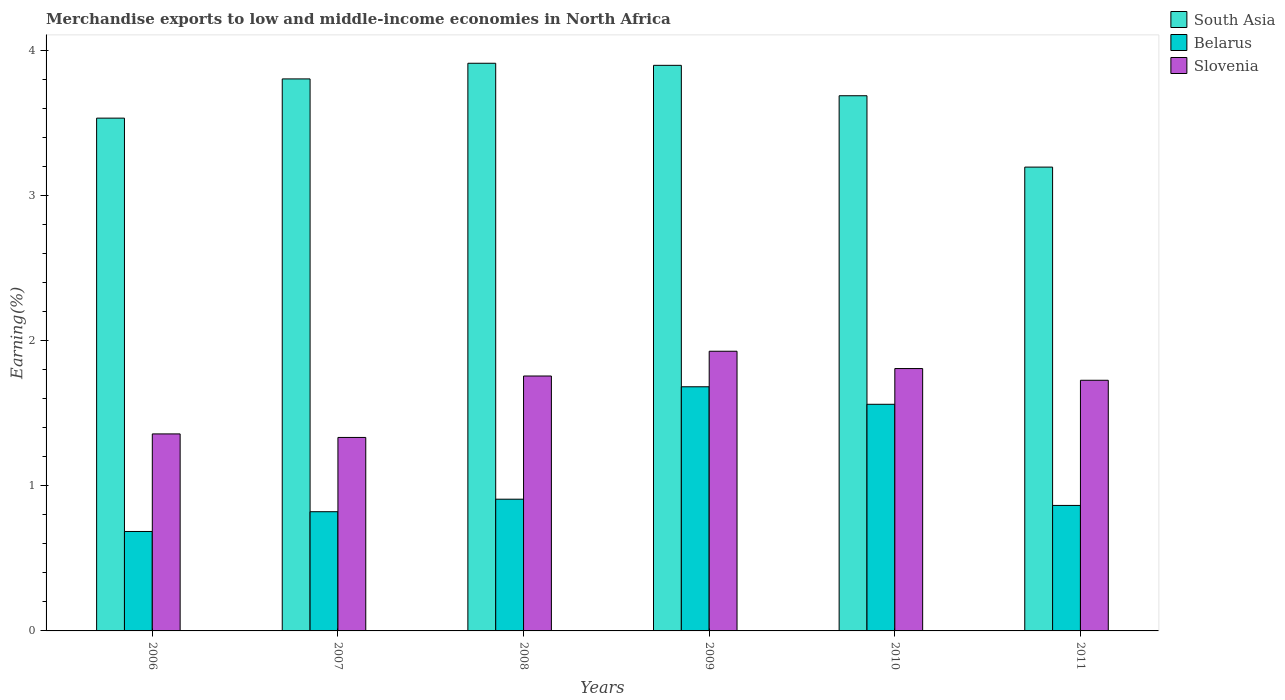How many different coloured bars are there?
Keep it short and to the point. 3. How many groups of bars are there?
Your response must be concise. 6. Are the number of bars on each tick of the X-axis equal?
Offer a terse response. Yes. How many bars are there on the 4th tick from the left?
Ensure brevity in your answer.  3. How many bars are there on the 1st tick from the right?
Offer a very short reply. 3. What is the percentage of amount earned from merchandise exports in South Asia in 2011?
Provide a short and direct response. 3.2. Across all years, what is the maximum percentage of amount earned from merchandise exports in Belarus?
Offer a very short reply. 1.68. Across all years, what is the minimum percentage of amount earned from merchandise exports in Slovenia?
Your answer should be compact. 1.33. What is the total percentage of amount earned from merchandise exports in South Asia in the graph?
Keep it short and to the point. 22.03. What is the difference between the percentage of amount earned from merchandise exports in Belarus in 2007 and that in 2011?
Keep it short and to the point. -0.04. What is the difference between the percentage of amount earned from merchandise exports in Belarus in 2009 and the percentage of amount earned from merchandise exports in Slovenia in 2006?
Keep it short and to the point. 0.32. What is the average percentage of amount earned from merchandise exports in Belarus per year?
Your answer should be very brief. 1.09. In the year 2007, what is the difference between the percentage of amount earned from merchandise exports in Belarus and percentage of amount earned from merchandise exports in South Asia?
Offer a very short reply. -2.98. In how many years, is the percentage of amount earned from merchandise exports in Belarus greater than 0.8 %?
Offer a terse response. 5. What is the ratio of the percentage of amount earned from merchandise exports in Belarus in 2007 to that in 2009?
Your answer should be compact. 0.49. What is the difference between the highest and the second highest percentage of amount earned from merchandise exports in Belarus?
Provide a short and direct response. 0.12. What is the difference between the highest and the lowest percentage of amount earned from merchandise exports in Belarus?
Offer a terse response. 1. Is the sum of the percentage of amount earned from merchandise exports in Slovenia in 2008 and 2010 greater than the maximum percentage of amount earned from merchandise exports in Belarus across all years?
Ensure brevity in your answer.  Yes. What does the 2nd bar from the left in 2008 represents?
Keep it short and to the point. Belarus. What does the 2nd bar from the right in 2010 represents?
Provide a short and direct response. Belarus. Is it the case that in every year, the sum of the percentage of amount earned from merchandise exports in Belarus and percentage of amount earned from merchandise exports in Slovenia is greater than the percentage of amount earned from merchandise exports in South Asia?
Provide a short and direct response. No. What is the difference between two consecutive major ticks on the Y-axis?
Your response must be concise. 1. Are the values on the major ticks of Y-axis written in scientific E-notation?
Offer a terse response. No. Does the graph contain grids?
Ensure brevity in your answer.  No. How many legend labels are there?
Your answer should be very brief. 3. How are the legend labels stacked?
Provide a short and direct response. Vertical. What is the title of the graph?
Provide a succinct answer. Merchandise exports to low and middle-income economies in North Africa. Does "Channel Islands" appear as one of the legend labels in the graph?
Your response must be concise. No. What is the label or title of the Y-axis?
Provide a succinct answer. Earning(%). What is the Earning(%) in South Asia in 2006?
Offer a very short reply. 3.53. What is the Earning(%) in Belarus in 2006?
Keep it short and to the point. 0.69. What is the Earning(%) of Slovenia in 2006?
Your answer should be very brief. 1.36. What is the Earning(%) in South Asia in 2007?
Your response must be concise. 3.8. What is the Earning(%) of Belarus in 2007?
Your answer should be very brief. 0.82. What is the Earning(%) of Slovenia in 2007?
Your answer should be compact. 1.33. What is the Earning(%) in South Asia in 2008?
Your answer should be compact. 3.91. What is the Earning(%) of Belarus in 2008?
Your response must be concise. 0.91. What is the Earning(%) in Slovenia in 2008?
Keep it short and to the point. 1.76. What is the Earning(%) of South Asia in 2009?
Offer a very short reply. 3.9. What is the Earning(%) in Belarus in 2009?
Your response must be concise. 1.68. What is the Earning(%) in Slovenia in 2009?
Provide a succinct answer. 1.93. What is the Earning(%) in South Asia in 2010?
Provide a short and direct response. 3.69. What is the Earning(%) of Belarus in 2010?
Your answer should be compact. 1.56. What is the Earning(%) of Slovenia in 2010?
Offer a terse response. 1.81. What is the Earning(%) of South Asia in 2011?
Offer a very short reply. 3.2. What is the Earning(%) of Belarus in 2011?
Your answer should be compact. 0.86. What is the Earning(%) in Slovenia in 2011?
Make the answer very short. 1.73. Across all years, what is the maximum Earning(%) in South Asia?
Keep it short and to the point. 3.91. Across all years, what is the maximum Earning(%) in Belarus?
Provide a short and direct response. 1.68. Across all years, what is the maximum Earning(%) of Slovenia?
Offer a very short reply. 1.93. Across all years, what is the minimum Earning(%) in South Asia?
Give a very brief answer. 3.2. Across all years, what is the minimum Earning(%) in Belarus?
Provide a short and direct response. 0.69. Across all years, what is the minimum Earning(%) in Slovenia?
Keep it short and to the point. 1.33. What is the total Earning(%) in South Asia in the graph?
Keep it short and to the point. 22.03. What is the total Earning(%) of Belarus in the graph?
Keep it short and to the point. 6.52. What is the total Earning(%) of Slovenia in the graph?
Give a very brief answer. 9.91. What is the difference between the Earning(%) in South Asia in 2006 and that in 2007?
Offer a terse response. -0.27. What is the difference between the Earning(%) of Belarus in 2006 and that in 2007?
Give a very brief answer. -0.14. What is the difference between the Earning(%) of Slovenia in 2006 and that in 2007?
Make the answer very short. 0.02. What is the difference between the Earning(%) in South Asia in 2006 and that in 2008?
Provide a short and direct response. -0.38. What is the difference between the Earning(%) of Belarus in 2006 and that in 2008?
Your answer should be very brief. -0.22. What is the difference between the Earning(%) in Slovenia in 2006 and that in 2008?
Ensure brevity in your answer.  -0.4. What is the difference between the Earning(%) in South Asia in 2006 and that in 2009?
Offer a very short reply. -0.36. What is the difference between the Earning(%) in Belarus in 2006 and that in 2009?
Provide a short and direct response. -1. What is the difference between the Earning(%) in Slovenia in 2006 and that in 2009?
Provide a succinct answer. -0.57. What is the difference between the Earning(%) in South Asia in 2006 and that in 2010?
Keep it short and to the point. -0.15. What is the difference between the Earning(%) of Belarus in 2006 and that in 2010?
Provide a succinct answer. -0.88. What is the difference between the Earning(%) of Slovenia in 2006 and that in 2010?
Provide a succinct answer. -0.45. What is the difference between the Earning(%) in South Asia in 2006 and that in 2011?
Your response must be concise. 0.34. What is the difference between the Earning(%) of Belarus in 2006 and that in 2011?
Your response must be concise. -0.18. What is the difference between the Earning(%) in Slovenia in 2006 and that in 2011?
Make the answer very short. -0.37. What is the difference between the Earning(%) of South Asia in 2007 and that in 2008?
Provide a succinct answer. -0.11. What is the difference between the Earning(%) in Belarus in 2007 and that in 2008?
Offer a terse response. -0.09. What is the difference between the Earning(%) of Slovenia in 2007 and that in 2008?
Offer a terse response. -0.42. What is the difference between the Earning(%) of South Asia in 2007 and that in 2009?
Offer a very short reply. -0.09. What is the difference between the Earning(%) of Belarus in 2007 and that in 2009?
Your response must be concise. -0.86. What is the difference between the Earning(%) of Slovenia in 2007 and that in 2009?
Your response must be concise. -0.59. What is the difference between the Earning(%) of South Asia in 2007 and that in 2010?
Ensure brevity in your answer.  0.12. What is the difference between the Earning(%) of Belarus in 2007 and that in 2010?
Provide a short and direct response. -0.74. What is the difference between the Earning(%) in Slovenia in 2007 and that in 2010?
Provide a succinct answer. -0.47. What is the difference between the Earning(%) of South Asia in 2007 and that in 2011?
Your answer should be very brief. 0.61. What is the difference between the Earning(%) in Belarus in 2007 and that in 2011?
Offer a very short reply. -0.04. What is the difference between the Earning(%) of Slovenia in 2007 and that in 2011?
Keep it short and to the point. -0.39. What is the difference between the Earning(%) in South Asia in 2008 and that in 2009?
Your answer should be compact. 0.01. What is the difference between the Earning(%) of Belarus in 2008 and that in 2009?
Provide a short and direct response. -0.77. What is the difference between the Earning(%) in Slovenia in 2008 and that in 2009?
Give a very brief answer. -0.17. What is the difference between the Earning(%) in South Asia in 2008 and that in 2010?
Offer a very short reply. 0.22. What is the difference between the Earning(%) in Belarus in 2008 and that in 2010?
Keep it short and to the point. -0.65. What is the difference between the Earning(%) of Slovenia in 2008 and that in 2010?
Provide a short and direct response. -0.05. What is the difference between the Earning(%) in South Asia in 2008 and that in 2011?
Your answer should be very brief. 0.72. What is the difference between the Earning(%) of Belarus in 2008 and that in 2011?
Your answer should be compact. 0.04. What is the difference between the Earning(%) in Slovenia in 2008 and that in 2011?
Keep it short and to the point. 0.03. What is the difference between the Earning(%) in South Asia in 2009 and that in 2010?
Offer a terse response. 0.21. What is the difference between the Earning(%) in Belarus in 2009 and that in 2010?
Your answer should be very brief. 0.12. What is the difference between the Earning(%) of Slovenia in 2009 and that in 2010?
Your response must be concise. 0.12. What is the difference between the Earning(%) in South Asia in 2009 and that in 2011?
Your answer should be compact. 0.7. What is the difference between the Earning(%) in Belarus in 2009 and that in 2011?
Keep it short and to the point. 0.82. What is the difference between the Earning(%) in Slovenia in 2009 and that in 2011?
Make the answer very short. 0.2. What is the difference between the Earning(%) in South Asia in 2010 and that in 2011?
Offer a terse response. 0.49. What is the difference between the Earning(%) in Belarus in 2010 and that in 2011?
Your answer should be compact. 0.7. What is the difference between the Earning(%) in Slovenia in 2010 and that in 2011?
Offer a terse response. 0.08. What is the difference between the Earning(%) in South Asia in 2006 and the Earning(%) in Belarus in 2007?
Offer a terse response. 2.71. What is the difference between the Earning(%) in South Asia in 2006 and the Earning(%) in Slovenia in 2007?
Offer a terse response. 2.2. What is the difference between the Earning(%) in Belarus in 2006 and the Earning(%) in Slovenia in 2007?
Your answer should be very brief. -0.65. What is the difference between the Earning(%) in South Asia in 2006 and the Earning(%) in Belarus in 2008?
Offer a terse response. 2.63. What is the difference between the Earning(%) of South Asia in 2006 and the Earning(%) of Slovenia in 2008?
Ensure brevity in your answer.  1.78. What is the difference between the Earning(%) of Belarus in 2006 and the Earning(%) of Slovenia in 2008?
Provide a short and direct response. -1.07. What is the difference between the Earning(%) in South Asia in 2006 and the Earning(%) in Belarus in 2009?
Your answer should be compact. 1.85. What is the difference between the Earning(%) in South Asia in 2006 and the Earning(%) in Slovenia in 2009?
Provide a short and direct response. 1.61. What is the difference between the Earning(%) of Belarus in 2006 and the Earning(%) of Slovenia in 2009?
Give a very brief answer. -1.24. What is the difference between the Earning(%) in South Asia in 2006 and the Earning(%) in Belarus in 2010?
Give a very brief answer. 1.97. What is the difference between the Earning(%) of South Asia in 2006 and the Earning(%) of Slovenia in 2010?
Your answer should be very brief. 1.73. What is the difference between the Earning(%) of Belarus in 2006 and the Earning(%) of Slovenia in 2010?
Give a very brief answer. -1.12. What is the difference between the Earning(%) of South Asia in 2006 and the Earning(%) of Belarus in 2011?
Your response must be concise. 2.67. What is the difference between the Earning(%) in South Asia in 2006 and the Earning(%) in Slovenia in 2011?
Give a very brief answer. 1.81. What is the difference between the Earning(%) in Belarus in 2006 and the Earning(%) in Slovenia in 2011?
Give a very brief answer. -1.04. What is the difference between the Earning(%) in South Asia in 2007 and the Earning(%) in Belarus in 2008?
Your response must be concise. 2.9. What is the difference between the Earning(%) of South Asia in 2007 and the Earning(%) of Slovenia in 2008?
Your response must be concise. 2.05. What is the difference between the Earning(%) of Belarus in 2007 and the Earning(%) of Slovenia in 2008?
Provide a short and direct response. -0.94. What is the difference between the Earning(%) of South Asia in 2007 and the Earning(%) of Belarus in 2009?
Provide a short and direct response. 2.12. What is the difference between the Earning(%) in South Asia in 2007 and the Earning(%) in Slovenia in 2009?
Your response must be concise. 1.88. What is the difference between the Earning(%) in Belarus in 2007 and the Earning(%) in Slovenia in 2009?
Provide a short and direct response. -1.11. What is the difference between the Earning(%) in South Asia in 2007 and the Earning(%) in Belarus in 2010?
Provide a succinct answer. 2.24. What is the difference between the Earning(%) of South Asia in 2007 and the Earning(%) of Slovenia in 2010?
Provide a short and direct response. 2. What is the difference between the Earning(%) of Belarus in 2007 and the Earning(%) of Slovenia in 2010?
Offer a terse response. -0.99. What is the difference between the Earning(%) in South Asia in 2007 and the Earning(%) in Belarus in 2011?
Provide a short and direct response. 2.94. What is the difference between the Earning(%) in South Asia in 2007 and the Earning(%) in Slovenia in 2011?
Your response must be concise. 2.08. What is the difference between the Earning(%) of Belarus in 2007 and the Earning(%) of Slovenia in 2011?
Your answer should be compact. -0.91. What is the difference between the Earning(%) in South Asia in 2008 and the Earning(%) in Belarus in 2009?
Keep it short and to the point. 2.23. What is the difference between the Earning(%) in South Asia in 2008 and the Earning(%) in Slovenia in 2009?
Your answer should be compact. 1.98. What is the difference between the Earning(%) in Belarus in 2008 and the Earning(%) in Slovenia in 2009?
Give a very brief answer. -1.02. What is the difference between the Earning(%) in South Asia in 2008 and the Earning(%) in Belarus in 2010?
Your response must be concise. 2.35. What is the difference between the Earning(%) of South Asia in 2008 and the Earning(%) of Slovenia in 2010?
Your answer should be compact. 2.1. What is the difference between the Earning(%) in Belarus in 2008 and the Earning(%) in Slovenia in 2010?
Provide a succinct answer. -0.9. What is the difference between the Earning(%) of South Asia in 2008 and the Earning(%) of Belarus in 2011?
Provide a short and direct response. 3.05. What is the difference between the Earning(%) of South Asia in 2008 and the Earning(%) of Slovenia in 2011?
Ensure brevity in your answer.  2.18. What is the difference between the Earning(%) in Belarus in 2008 and the Earning(%) in Slovenia in 2011?
Provide a succinct answer. -0.82. What is the difference between the Earning(%) of South Asia in 2009 and the Earning(%) of Belarus in 2010?
Provide a succinct answer. 2.34. What is the difference between the Earning(%) of South Asia in 2009 and the Earning(%) of Slovenia in 2010?
Offer a very short reply. 2.09. What is the difference between the Earning(%) of Belarus in 2009 and the Earning(%) of Slovenia in 2010?
Give a very brief answer. -0.13. What is the difference between the Earning(%) in South Asia in 2009 and the Earning(%) in Belarus in 2011?
Ensure brevity in your answer.  3.03. What is the difference between the Earning(%) of South Asia in 2009 and the Earning(%) of Slovenia in 2011?
Provide a short and direct response. 2.17. What is the difference between the Earning(%) of Belarus in 2009 and the Earning(%) of Slovenia in 2011?
Your response must be concise. -0.04. What is the difference between the Earning(%) in South Asia in 2010 and the Earning(%) in Belarus in 2011?
Provide a succinct answer. 2.82. What is the difference between the Earning(%) of South Asia in 2010 and the Earning(%) of Slovenia in 2011?
Provide a short and direct response. 1.96. What is the difference between the Earning(%) in Belarus in 2010 and the Earning(%) in Slovenia in 2011?
Provide a short and direct response. -0.17. What is the average Earning(%) of South Asia per year?
Make the answer very short. 3.67. What is the average Earning(%) in Belarus per year?
Your response must be concise. 1.09. What is the average Earning(%) in Slovenia per year?
Provide a succinct answer. 1.65. In the year 2006, what is the difference between the Earning(%) of South Asia and Earning(%) of Belarus?
Keep it short and to the point. 2.85. In the year 2006, what is the difference between the Earning(%) of South Asia and Earning(%) of Slovenia?
Your answer should be compact. 2.18. In the year 2006, what is the difference between the Earning(%) of Belarus and Earning(%) of Slovenia?
Make the answer very short. -0.67. In the year 2007, what is the difference between the Earning(%) of South Asia and Earning(%) of Belarus?
Provide a succinct answer. 2.98. In the year 2007, what is the difference between the Earning(%) in South Asia and Earning(%) in Slovenia?
Offer a terse response. 2.47. In the year 2007, what is the difference between the Earning(%) in Belarus and Earning(%) in Slovenia?
Your response must be concise. -0.51. In the year 2008, what is the difference between the Earning(%) in South Asia and Earning(%) in Belarus?
Provide a succinct answer. 3. In the year 2008, what is the difference between the Earning(%) of South Asia and Earning(%) of Slovenia?
Make the answer very short. 2.16. In the year 2008, what is the difference between the Earning(%) of Belarus and Earning(%) of Slovenia?
Ensure brevity in your answer.  -0.85. In the year 2009, what is the difference between the Earning(%) in South Asia and Earning(%) in Belarus?
Give a very brief answer. 2.21. In the year 2009, what is the difference between the Earning(%) of South Asia and Earning(%) of Slovenia?
Your response must be concise. 1.97. In the year 2009, what is the difference between the Earning(%) of Belarus and Earning(%) of Slovenia?
Ensure brevity in your answer.  -0.24. In the year 2010, what is the difference between the Earning(%) of South Asia and Earning(%) of Belarus?
Offer a very short reply. 2.13. In the year 2010, what is the difference between the Earning(%) of South Asia and Earning(%) of Slovenia?
Provide a succinct answer. 1.88. In the year 2010, what is the difference between the Earning(%) of Belarus and Earning(%) of Slovenia?
Give a very brief answer. -0.25. In the year 2011, what is the difference between the Earning(%) of South Asia and Earning(%) of Belarus?
Provide a short and direct response. 2.33. In the year 2011, what is the difference between the Earning(%) in South Asia and Earning(%) in Slovenia?
Offer a very short reply. 1.47. In the year 2011, what is the difference between the Earning(%) of Belarus and Earning(%) of Slovenia?
Your answer should be compact. -0.86. What is the ratio of the Earning(%) of South Asia in 2006 to that in 2007?
Offer a very short reply. 0.93. What is the ratio of the Earning(%) in Belarus in 2006 to that in 2007?
Your answer should be compact. 0.83. What is the ratio of the Earning(%) in Slovenia in 2006 to that in 2007?
Provide a succinct answer. 1.02. What is the ratio of the Earning(%) in South Asia in 2006 to that in 2008?
Provide a short and direct response. 0.9. What is the ratio of the Earning(%) in Belarus in 2006 to that in 2008?
Provide a succinct answer. 0.75. What is the ratio of the Earning(%) of Slovenia in 2006 to that in 2008?
Your response must be concise. 0.77. What is the ratio of the Earning(%) in South Asia in 2006 to that in 2009?
Your response must be concise. 0.91. What is the ratio of the Earning(%) in Belarus in 2006 to that in 2009?
Provide a short and direct response. 0.41. What is the ratio of the Earning(%) in Slovenia in 2006 to that in 2009?
Provide a succinct answer. 0.7. What is the ratio of the Earning(%) in South Asia in 2006 to that in 2010?
Give a very brief answer. 0.96. What is the ratio of the Earning(%) in Belarus in 2006 to that in 2010?
Provide a short and direct response. 0.44. What is the ratio of the Earning(%) in Slovenia in 2006 to that in 2010?
Ensure brevity in your answer.  0.75. What is the ratio of the Earning(%) of South Asia in 2006 to that in 2011?
Your answer should be compact. 1.11. What is the ratio of the Earning(%) of Belarus in 2006 to that in 2011?
Make the answer very short. 0.79. What is the ratio of the Earning(%) in Slovenia in 2006 to that in 2011?
Keep it short and to the point. 0.79. What is the ratio of the Earning(%) in South Asia in 2007 to that in 2008?
Offer a terse response. 0.97. What is the ratio of the Earning(%) in Belarus in 2007 to that in 2008?
Ensure brevity in your answer.  0.91. What is the ratio of the Earning(%) in Slovenia in 2007 to that in 2008?
Give a very brief answer. 0.76. What is the ratio of the Earning(%) of Belarus in 2007 to that in 2009?
Give a very brief answer. 0.49. What is the ratio of the Earning(%) of Slovenia in 2007 to that in 2009?
Offer a terse response. 0.69. What is the ratio of the Earning(%) in South Asia in 2007 to that in 2010?
Give a very brief answer. 1.03. What is the ratio of the Earning(%) of Belarus in 2007 to that in 2010?
Give a very brief answer. 0.53. What is the ratio of the Earning(%) in Slovenia in 2007 to that in 2010?
Your answer should be compact. 0.74. What is the ratio of the Earning(%) of South Asia in 2007 to that in 2011?
Keep it short and to the point. 1.19. What is the ratio of the Earning(%) of Slovenia in 2007 to that in 2011?
Your answer should be very brief. 0.77. What is the ratio of the Earning(%) of Belarus in 2008 to that in 2009?
Ensure brevity in your answer.  0.54. What is the ratio of the Earning(%) in Slovenia in 2008 to that in 2009?
Offer a very short reply. 0.91. What is the ratio of the Earning(%) of South Asia in 2008 to that in 2010?
Give a very brief answer. 1.06. What is the ratio of the Earning(%) of Belarus in 2008 to that in 2010?
Give a very brief answer. 0.58. What is the ratio of the Earning(%) in Slovenia in 2008 to that in 2010?
Make the answer very short. 0.97. What is the ratio of the Earning(%) of South Asia in 2008 to that in 2011?
Offer a terse response. 1.22. What is the ratio of the Earning(%) in Belarus in 2008 to that in 2011?
Offer a terse response. 1.05. What is the ratio of the Earning(%) in South Asia in 2009 to that in 2010?
Offer a terse response. 1.06. What is the ratio of the Earning(%) of Belarus in 2009 to that in 2010?
Your response must be concise. 1.08. What is the ratio of the Earning(%) of Slovenia in 2009 to that in 2010?
Provide a short and direct response. 1.07. What is the ratio of the Earning(%) of South Asia in 2009 to that in 2011?
Your answer should be very brief. 1.22. What is the ratio of the Earning(%) in Belarus in 2009 to that in 2011?
Provide a succinct answer. 1.95. What is the ratio of the Earning(%) in Slovenia in 2009 to that in 2011?
Keep it short and to the point. 1.12. What is the ratio of the Earning(%) of South Asia in 2010 to that in 2011?
Ensure brevity in your answer.  1.15. What is the ratio of the Earning(%) of Belarus in 2010 to that in 2011?
Offer a very short reply. 1.81. What is the ratio of the Earning(%) in Slovenia in 2010 to that in 2011?
Provide a succinct answer. 1.05. What is the difference between the highest and the second highest Earning(%) of South Asia?
Provide a succinct answer. 0.01. What is the difference between the highest and the second highest Earning(%) in Belarus?
Provide a succinct answer. 0.12. What is the difference between the highest and the second highest Earning(%) in Slovenia?
Your response must be concise. 0.12. What is the difference between the highest and the lowest Earning(%) in South Asia?
Ensure brevity in your answer.  0.72. What is the difference between the highest and the lowest Earning(%) of Slovenia?
Your response must be concise. 0.59. 